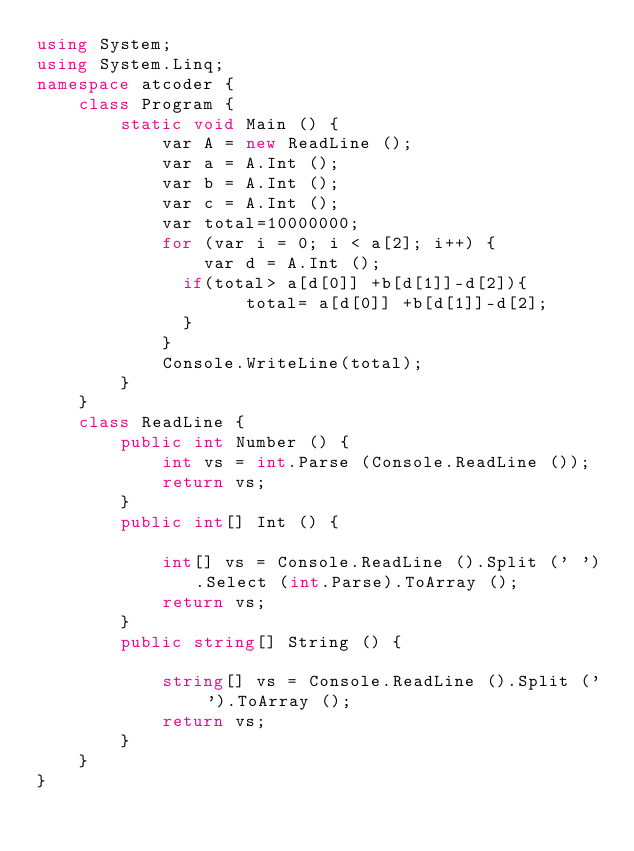Convert code to text. <code><loc_0><loc_0><loc_500><loc_500><_C#_>using System;
using System.Linq;
namespace atcoder {
    class Program {
        static void Main () {
            var A = new ReadLine ();
            var a = A.Int ();
            var b = A.Int ();
            var c = A.Int ();
            var total=10000000;
            for (var i = 0; i < a[2]; i++) {
                var d = A.Int ();
              if(total> a[d[0]] +b[d[1]]-d[2]){
                    total= a[d[0]] +b[d[1]]-d[2];
              }
            }
            Console.WriteLine(total);
        }
    }
    class ReadLine {
        public int Number () {
            int vs = int.Parse (Console.ReadLine ());
            return vs;
        }
        public int[] Int () {

            int[] vs = Console.ReadLine ().Split (' ').Select (int.Parse).ToArray ();
            return vs;
        }
        public string[] String () {

            string[] vs = Console.ReadLine ().Split (' ').ToArray ();
            return vs;
        }
    }
}</code> 